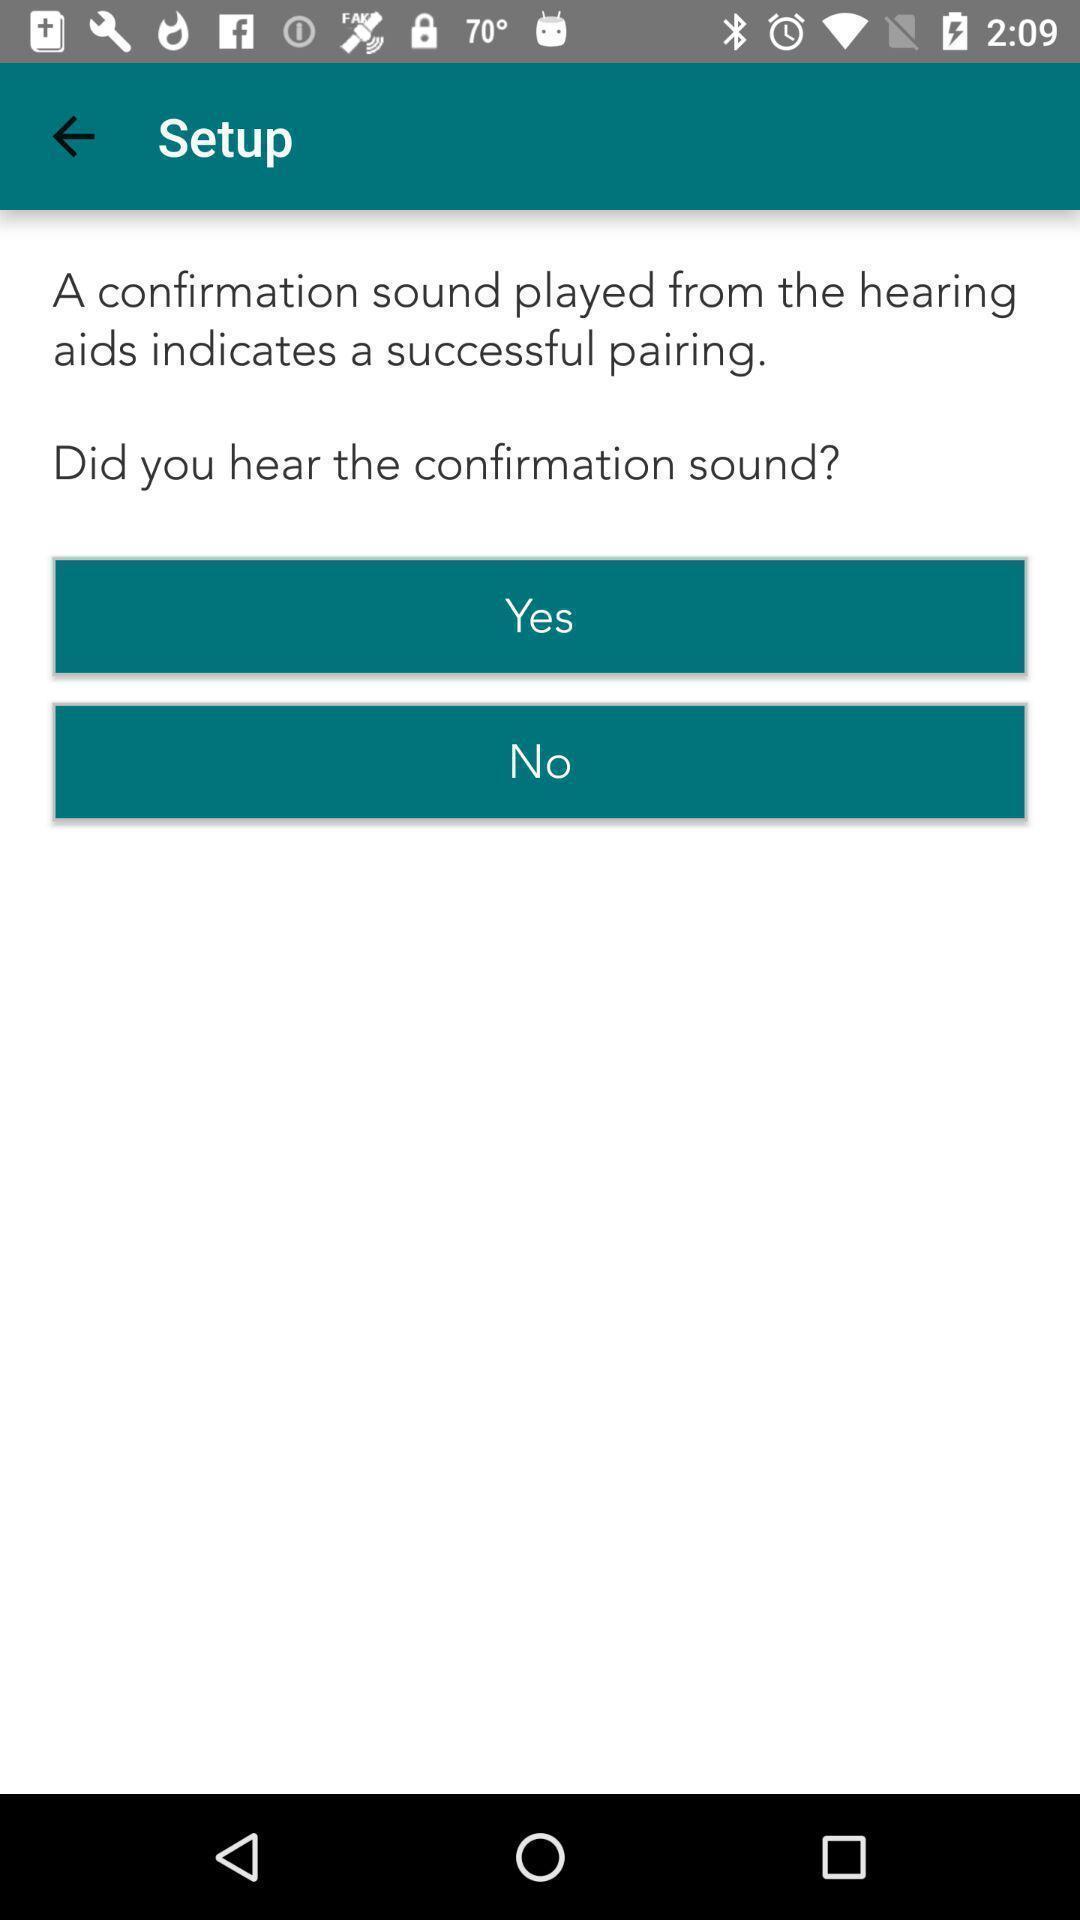Provide a textual representation of this image. Setup page displaying. 